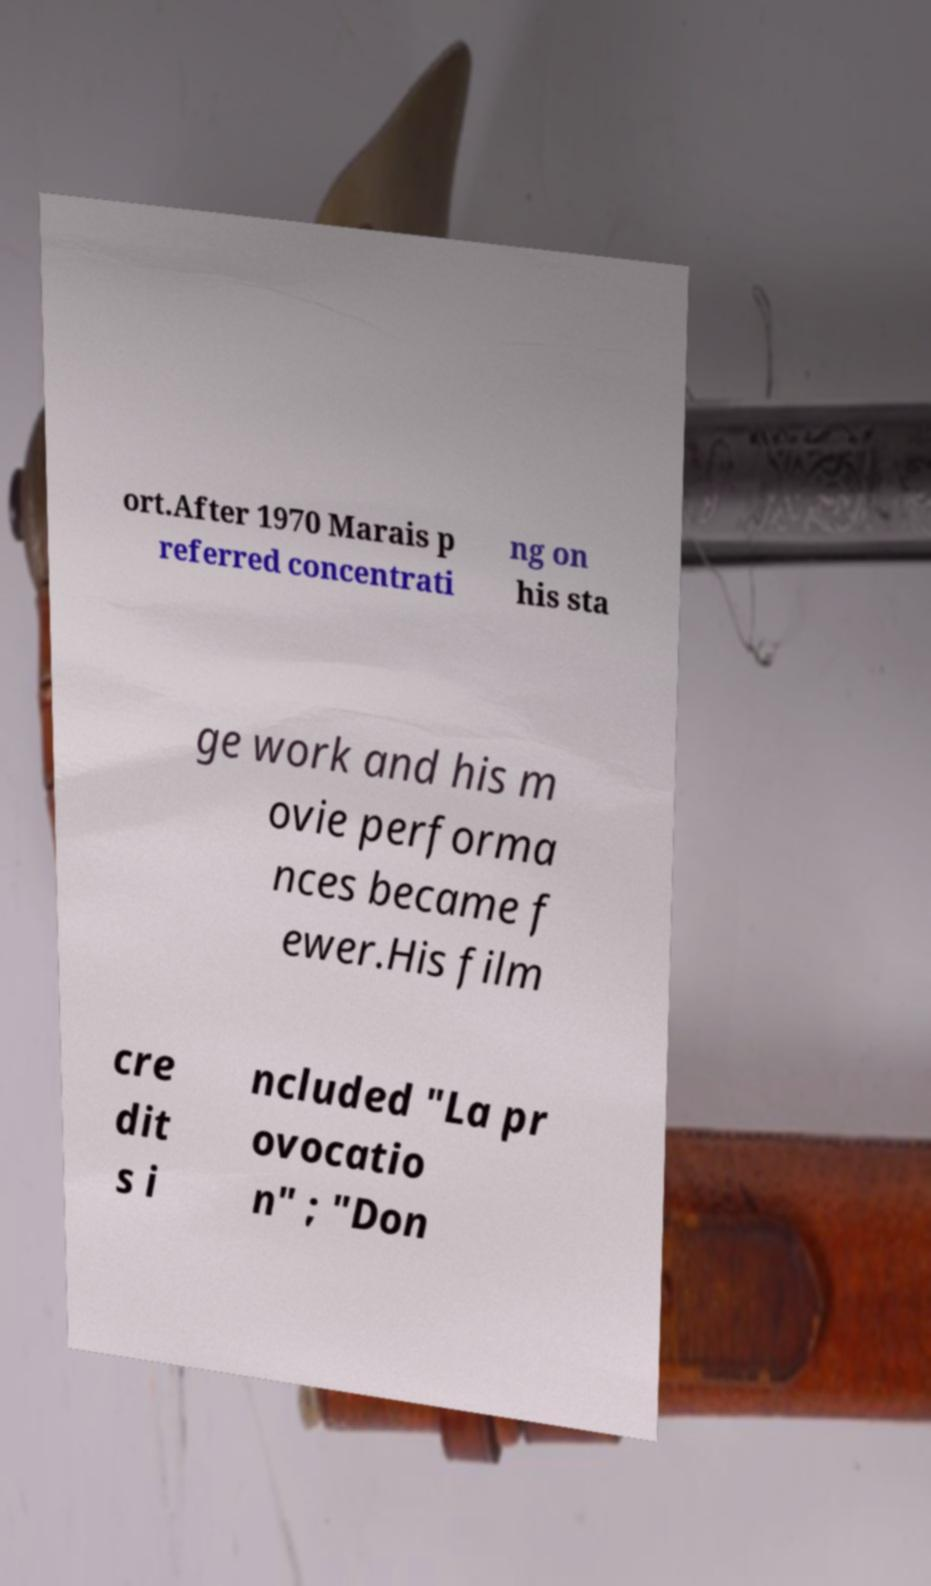Could you assist in decoding the text presented in this image and type it out clearly? ort.After 1970 Marais p referred concentrati ng on his sta ge work and his m ovie performa nces became f ewer.His film cre dit s i ncluded "La pr ovocatio n" ; "Don 